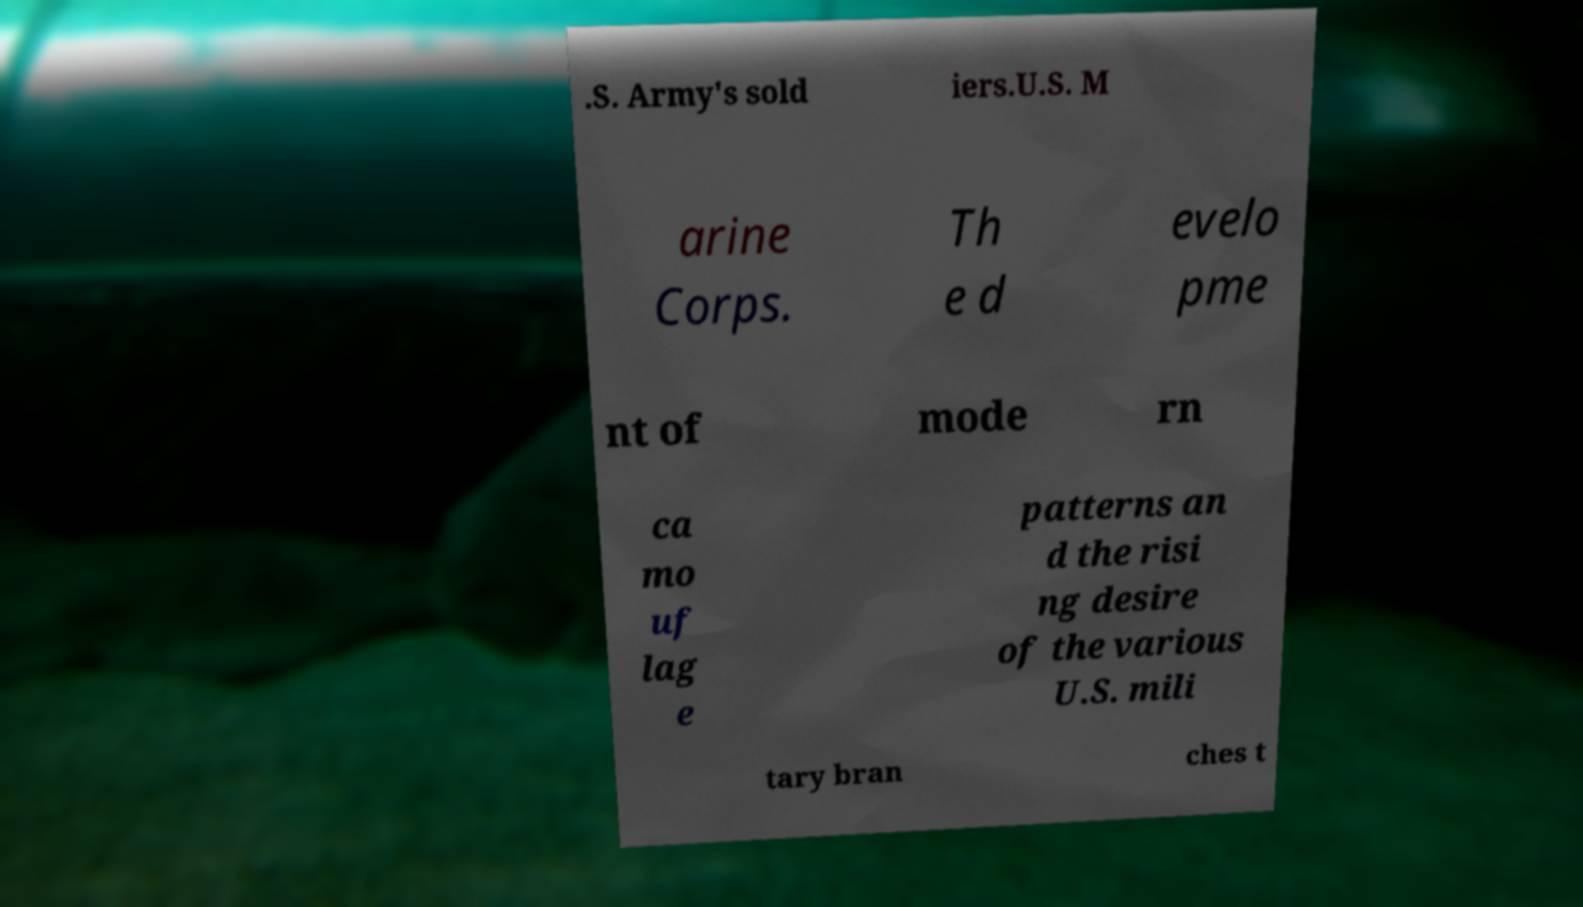What messages or text are displayed in this image? I need them in a readable, typed format. .S. Army's sold iers.U.S. M arine Corps. Th e d evelo pme nt of mode rn ca mo uf lag e patterns an d the risi ng desire of the various U.S. mili tary bran ches t 